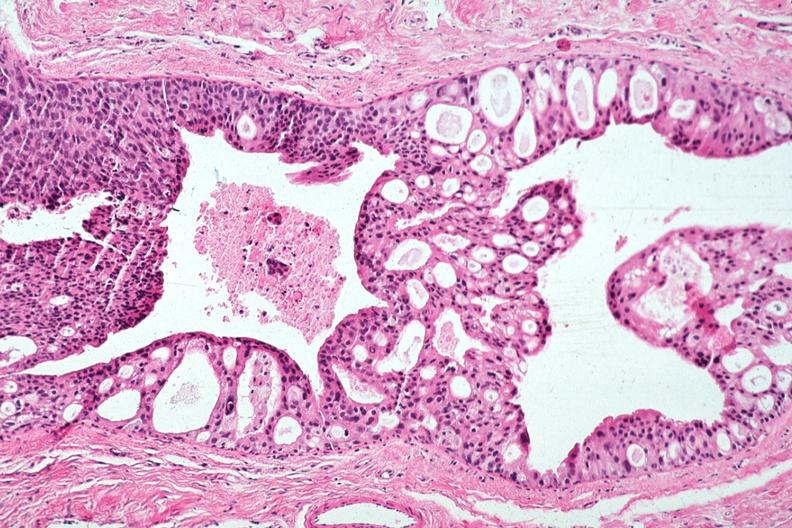where is this area in the body?
Answer the question using a single word or phrase. Breast 